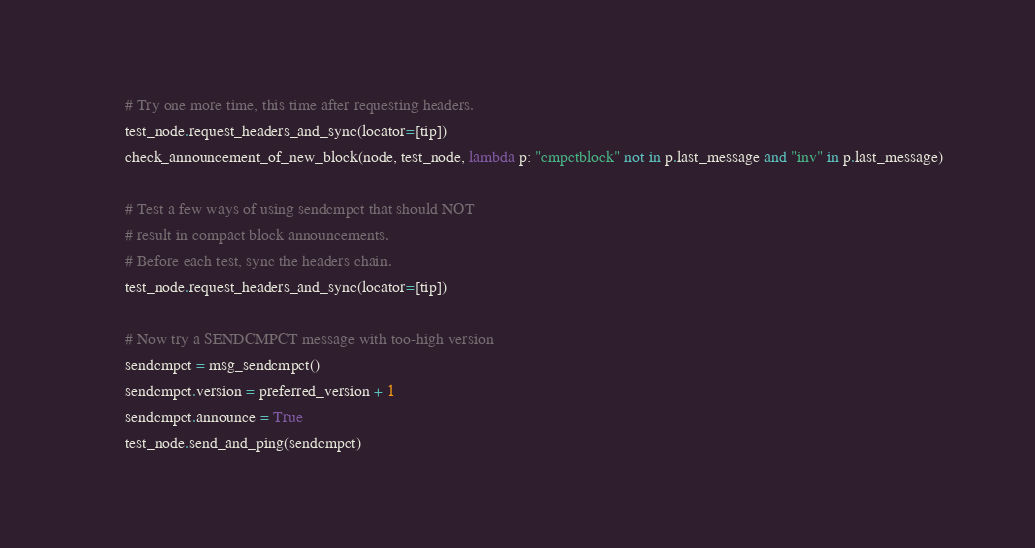<code> <loc_0><loc_0><loc_500><loc_500><_Python_>        # Try one more time, this time after requesting headers.
        test_node.request_headers_and_sync(locator=[tip])
        check_announcement_of_new_block(node, test_node, lambda p: "cmpctblock" not in p.last_message and "inv" in p.last_message)

        # Test a few ways of using sendcmpct that should NOT
        # result in compact block announcements.
        # Before each test, sync the headers chain.
        test_node.request_headers_and_sync(locator=[tip])

        # Now try a SENDCMPCT message with too-high version
        sendcmpct = msg_sendcmpct()
        sendcmpct.version = preferred_version + 1
        sendcmpct.announce = True
        test_node.send_and_ping(sendcmpct)</code> 